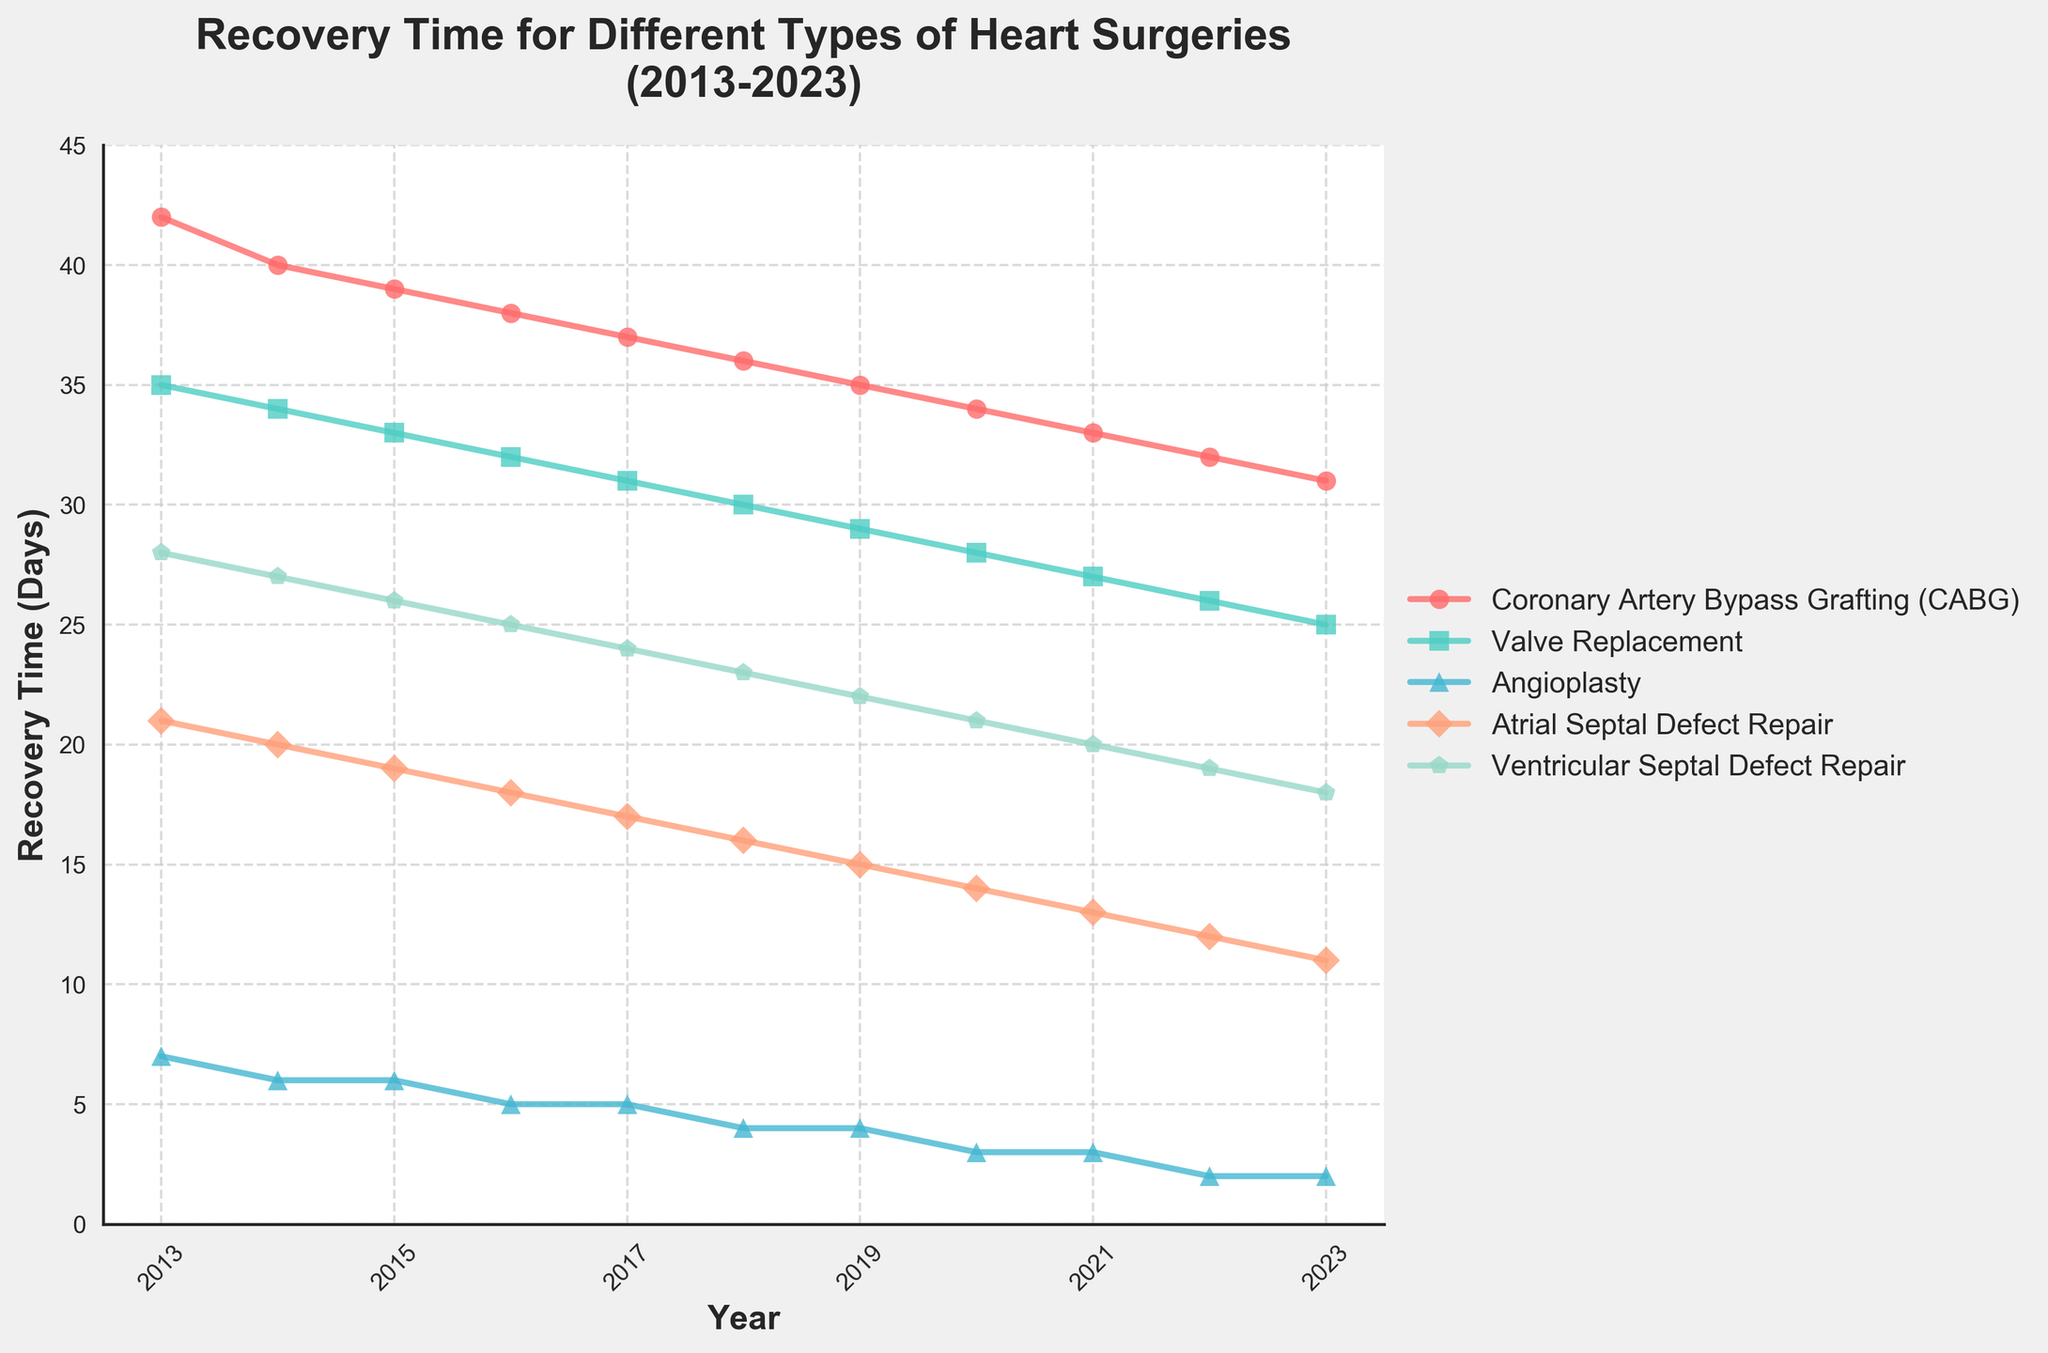What is the trend in recovery time for Coronary Artery Bypass Grafting (CABG) from 2013 to 2023? The line for CABG consistently decreases from 42 days in 2013 to 31 days in 2023, indicating a downward trend.
Answer: Downward trend Which surgery has the shortest recovery time in 2023? The line for Angioplasty is at 2 days in 2023, which is the lowest among all surgeries listed.
Answer: Angioplasty What was the recovery time difference between Valve Replacement and Atrial Septal Defect Repair in 2020? In 2020, Valve Replacement had a recovery time of 28 days, and Atrial Septal Defect Repair had 14 days. The difference is 28 - 14 = 14 days.
Answer: 14 days Among these surgeries, which one showed the most significant decrease in recovery time over the decade? CABG recovery time dropped from 42 days in 2013 to 31 days in 2023, a decrease of 11 days. Reviewing all surgeries, CABG shows the most significant decrease.
Answer: CABG Compare the recovery times of Angioplasty and Ventricular Septal Defect Repair in 2017. Which had a shorter recovery time and by how many days? In 2017, Angioplasty had a recovery time of 5 days, while Ventricular Septal Defect Repair had 24 days. The difference is 24 - 5 = 19 days. Angioplasty had a shorter recovery time by 19 days.
Answer: Angioplasty, 19 days What is the average recovery time for Valve Replacement over the available years? The recovery times for Valve Replacement from 2013 to 2023 are [35, 34, 33, 32, 31, 30, 29, 28, 27, 26, 25]. Sum them up to get 330 and divide by the number of years (11). 330 / 11 = 30.
Answer: 30 days Which year shows the greatest difference in recovery time between CABG and Angioplasty? The greatest difference is observed in 2013, where CABG has 42 days, and Angioplasty has 7 days. The difference is 42 - 7 = 35 days.
Answer: 2013 How much did the recovery time for Atrial Septal Defect Repair decrease from 2013 to 2023? The recovery time for Atrial Septal Defect Repair decreased from 21 days in 2013 to 11 days in 2023, a decrease of 21 - 11 = 10 days.
Answer: 10 days 